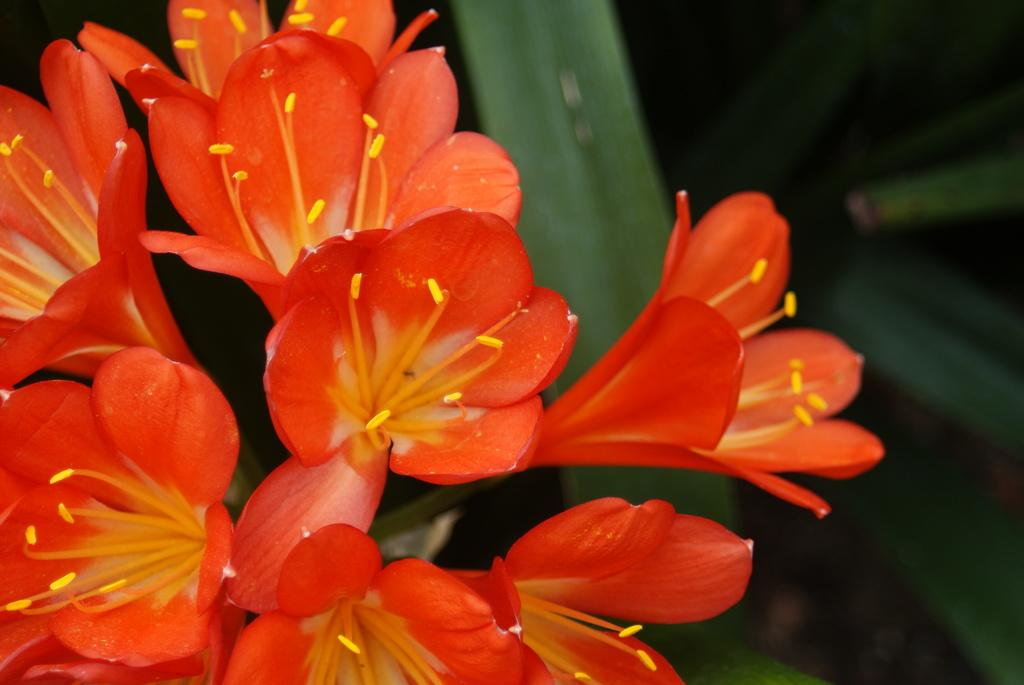What type of flowers can be seen in the image? There are red color flowers in the image. What color are the leaves in the background of the image? There are green color leaves in the background of the image. What type of bike is the governor riding in the image? There is no bike or governor present in the image; it only features red flowers and green leaves. 